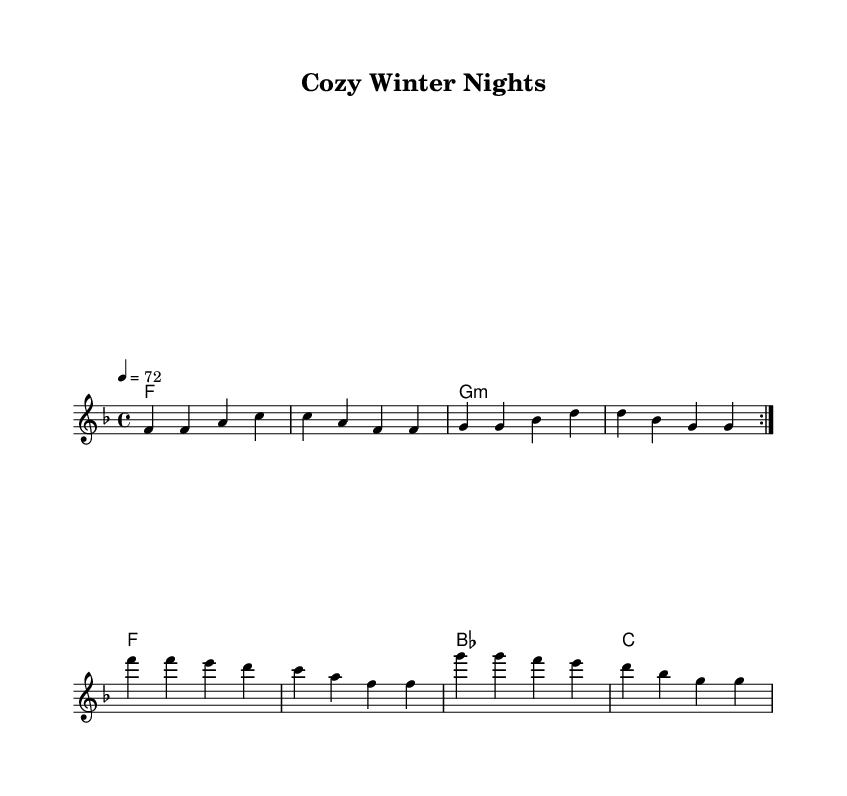What is the key signature of this music? The key signature is F major, which has one flat (B flat). You can determine this from the key indication at the beginning of the score, which is stated as "f \major."
Answer: F major What is the time signature of this piece? The time signature is 4/4. This is visible at the beginning of the score where the time signature is notated clearly as "4/4."
Answer: 4/4 What is the indicated tempo? The indicated tempo is 72 beats per minute. This is mentioned in the header section as "4 = 72," indicating the speed of the music.
Answer: 72 How many times is the first section repeated? The first section is repeated two times. This is indicated by the notation "\repeat volta 2" before the melody starts, showing that it should be played twice.
Answer: 2 What is the primary emotion conveyed in the lyrics of the chorus? The primary emotion conveyed in the lyrics of the chorus is warmth and safety. The lyrics express feelings of comfort and being at home during cozy winter nights. This can be inferred from phrases like "Warm and safe at home."
Answer: Warmth and safety Which chord appears most frequently in the harmonies? The F major chord appears most frequently. You can find it in the harmonic progression, occurring multiple times and being the first chord in both repeat sections.
Answer: F major 